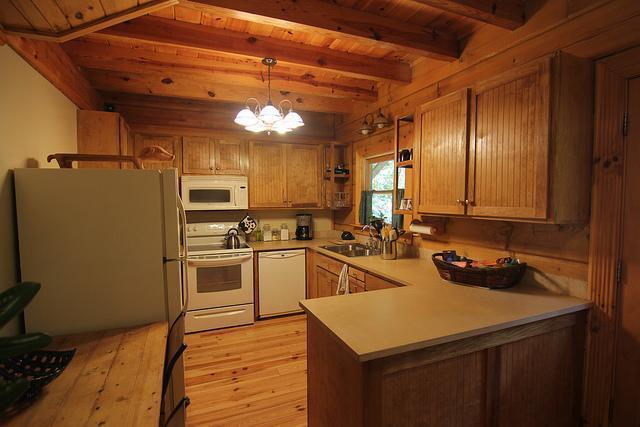What are the brightest lights attached to?
Choose the correct response and explain in the format: 'Answer: answer
Rationale: rationale.'
Options: Arena entrance, ceiling, computer, car. Answer: ceiling.
Rationale: It is attached to the ceiling to see in the whole area. 